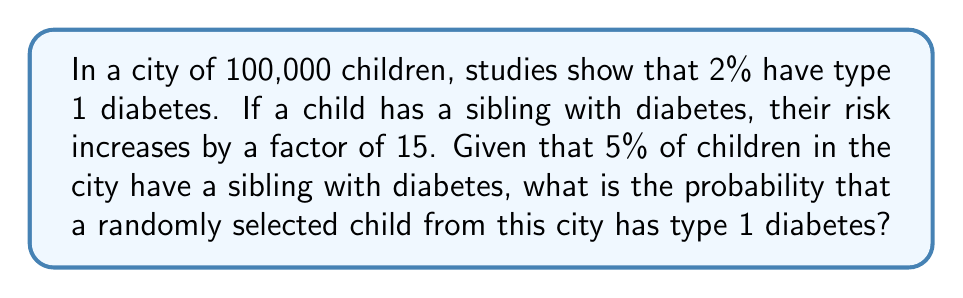Teach me how to tackle this problem. Let's approach this step-by-step:

1) First, let's define our events:
   A: Child has type 1 diabetes
   B: Child has a sibling with diabetes

2) We're given the following information:
   P(A) = 2% = 0.02 (base probability of having type 1 diabetes)
   P(B) = 5% = 0.05 (probability of having a sibling with diabetes)
   P(A|B) = 15 * P(A) = 15 * 0.02 = 0.3 (probability of having diabetes given a sibling has it)

3) We can use the law of total probability:
   $$P(A) = P(A|B) * P(B) + P(A|\text{not B}) * P(\text{not B})$$

4) We know P(A|B), P(B), and P(A). We need to find P(A|not B):
   0.02 = 0.3 * 0.05 + P(A|\text{not B}) * 0.95

5) Solving for P(A|not B):
   $$P(A|\text{not B}) = \frac{0.02 - 0.3 * 0.05}{0.95} = 0.0142$$

6) Now we can calculate the total probability:
   $$P(A) = 0.3 * 0.05 + 0.0142 * 0.95 = 0.015 + 0.01349 = 0.02849$$

7) Converting to a percentage:
   0.02849 * 100 = 2.849%

This means that the probability of a randomly selected child having type 1 diabetes, considering both family history and environmental factors, is approximately 2.849%.
Answer: 2.849% 